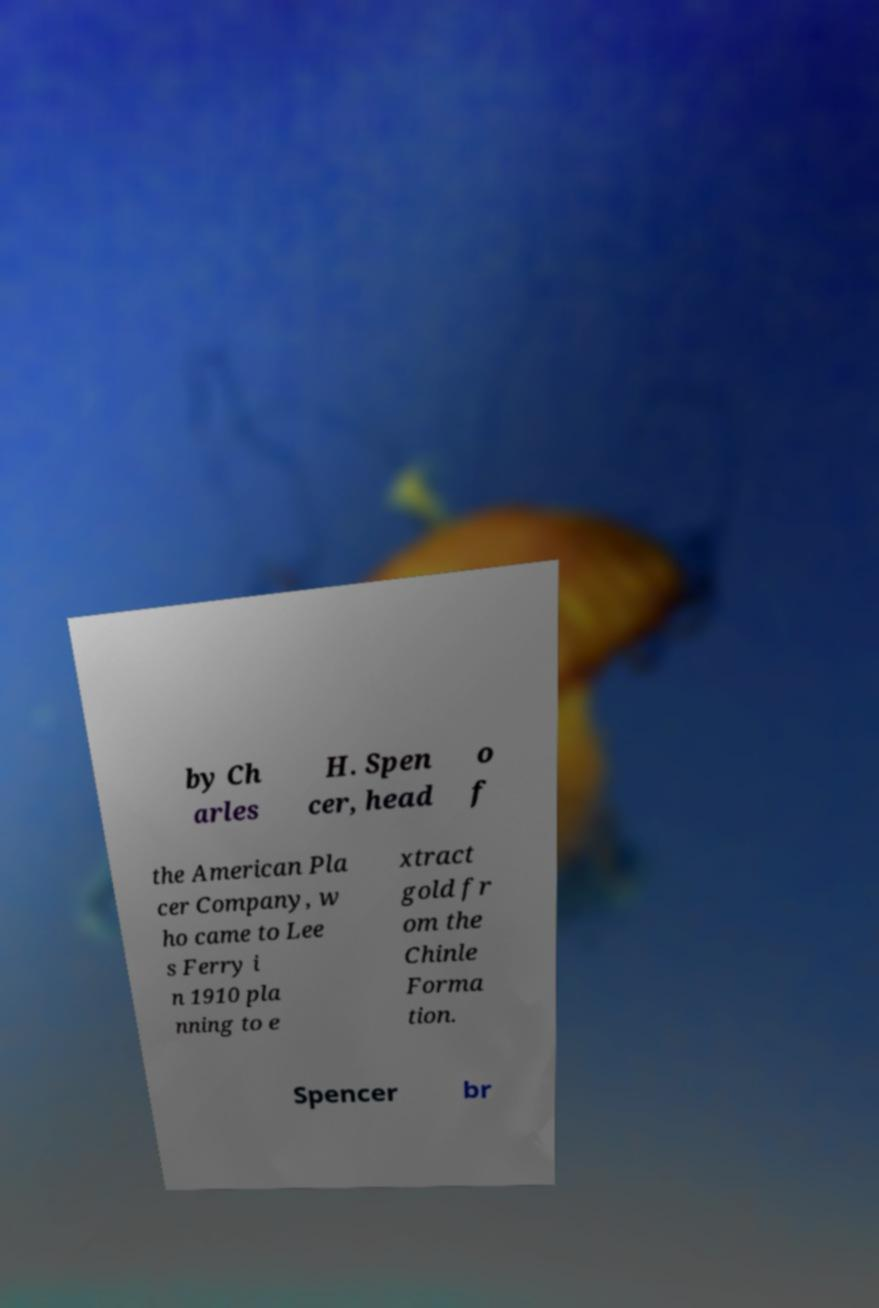Could you extract and type out the text from this image? by Ch arles H. Spen cer, head o f the American Pla cer Company, w ho came to Lee s Ferry i n 1910 pla nning to e xtract gold fr om the Chinle Forma tion. Spencer br 